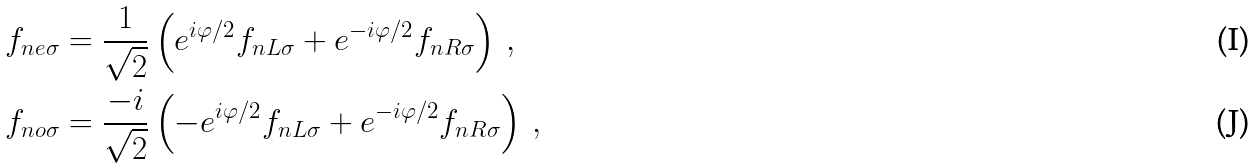Convert formula to latex. <formula><loc_0><loc_0><loc_500><loc_500>f _ { n e \sigma } & = \frac { 1 } { \sqrt { 2 } } \left ( e ^ { i \varphi / 2 } f _ { n L \sigma } + e ^ { - i \varphi / 2 } f _ { n R \sigma } \right ) \, , \\ f _ { n o \sigma } & = \frac { - i } { \sqrt { 2 } } \left ( - e ^ { i \varphi / 2 } f _ { n L \sigma } + e ^ { - i \varphi / 2 } f _ { n R \sigma } \right ) \, ,</formula> 